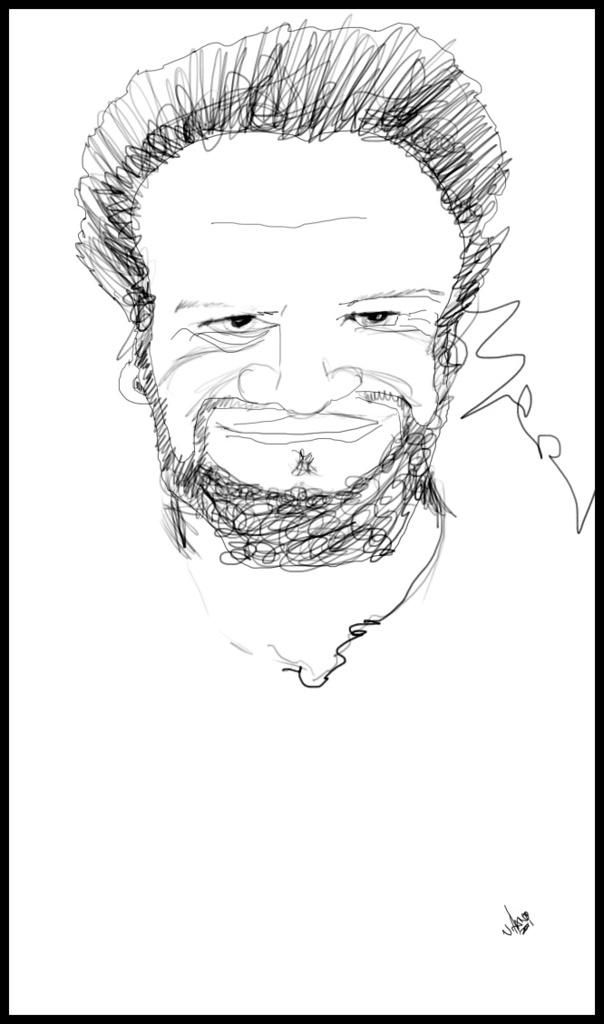What is the main subject of the image? The main subject of the image is a rough sketch of a man. What type of berry is depicted in the man's hand in the image? There is no berry depicted in the man's hand in the image, as the image is a rough sketch of a man and does not include any additional objects or elements. 